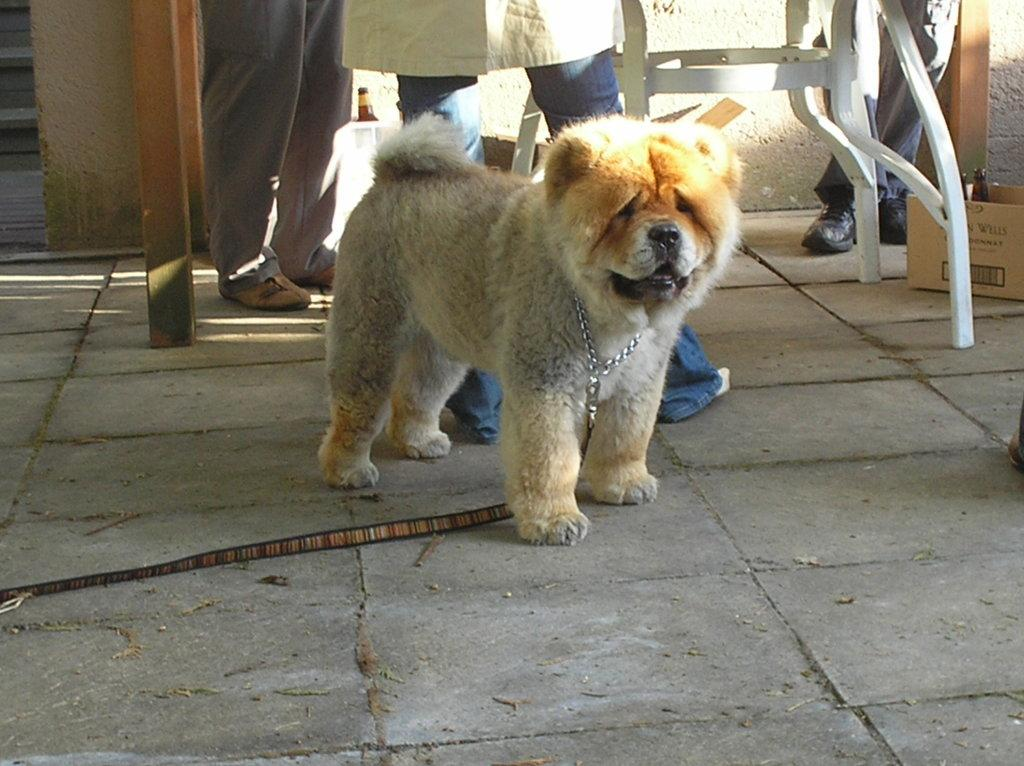What type of animal is in the image? There is a puppy in the image. Where is the puppy located in the image? The puppy is standing on the floor. What else can be seen in the image besides the puppy? There are people standing around a table in the image. What type of car is visible in the image? There is no car present in the image; it features a puppy standing on the floor and people standing around a table. 